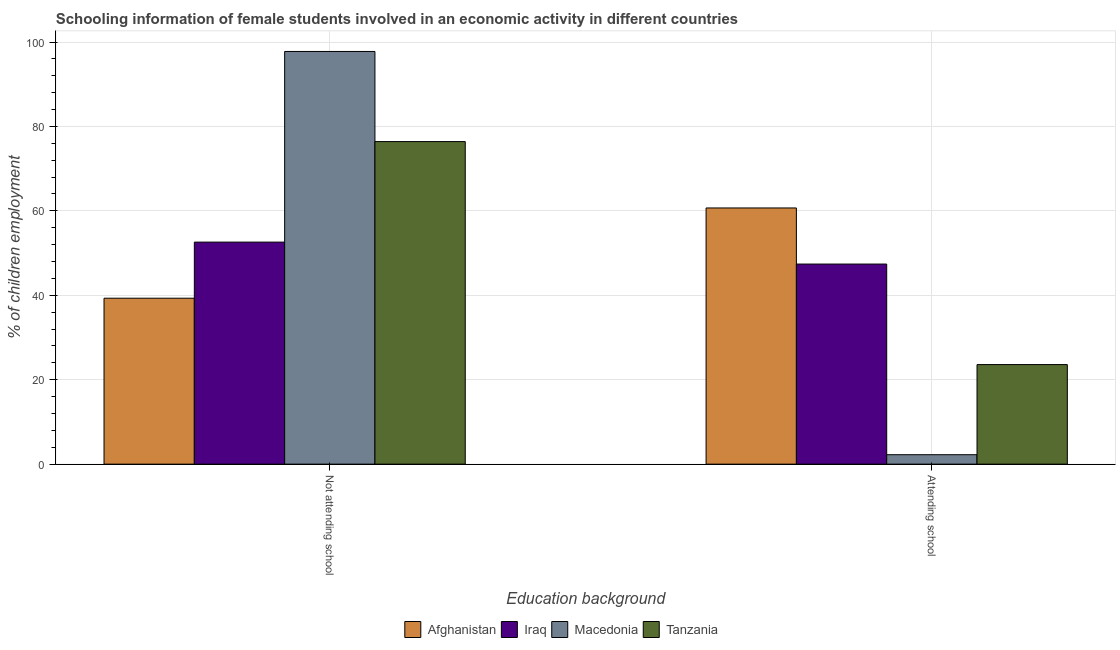How many different coloured bars are there?
Your answer should be very brief. 4. How many groups of bars are there?
Keep it short and to the point. 2. Are the number of bars on each tick of the X-axis equal?
Offer a very short reply. Yes. How many bars are there on the 1st tick from the left?
Make the answer very short. 4. How many bars are there on the 1st tick from the right?
Ensure brevity in your answer.  4. What is the label of the 1st group of bars from the left?
Make the answer very short. Not attending school. What is the percentage of employed females who are attending school in Iraq?
Provide a short and direct response. 47.4. Across all countries, what is the maximum percentage of employed females who are attending school?
Offer a very short reply. 60.69. Across all countries, what is the minimum percentage of employed females who are not attending school?
Offer a terse response. 39.31. In which country was the percentage of employed females who are attending school maximum?
Provide a succinct answer. Afghanistan. In which country was the percentage of employed females who are not attending school minimum?
Your response must be concise. Afghanistan. What is the total percentage of employed females who are attending school in the graph?
Your answer should be compact. 133.91. What is the difference between the percentage of employed females who are attending school in Macedonia and that in Iraq?
Offer a terse response. -45.16. What is the difference between the percentage of employed females who are attending school in Afghanistan and the percentage of employed females who are not attending school in Macedonia?
Give a very brief answer. -37.07. What is the average percentage of employed females who are attending school per country?
Offer a terse response. 33.48. What is the difference between the percentage of employed females who are attending school and percentage of employed females who are not attending school in Tanzania?
Provide a succinct answer. -52.83. What is the ratio of the percentage of employed females who are not attending school in Iraq to that in Macedonia?
Give a very brief answer. 0.54. Is the percentage of employed females who are attending school in Tanzania less than that in Afghanistan?
Offer a very short reply. Yes. What does the 1st bar from the left in Attending school represents?
Ensure brevity in your answer.  Afghanistan. What does the 2nd bar from the right in Not attending school represents?
Your answer should be compact. Macedonia. Are all the bars in the graph horizontal?
Offer a very short reply. No. Are the values on the major ticks of Y-axis written in scientific E-notation?
Make the answer very short. No. Does the graph contain grids?
Make the answer very short. Yes. How many legend labels are there?
Make the answer very short. 4. How are the legend labels stacked?
Your response must be concise. Horizontal. What is the title of the graph?
Provide a succinct answer. Schooling information of female students involved in an economic activity in different countries. What is the label or title of the X-axis?
Keep it short and to the point. Education background. What is the label or title of the Y-axis?
Make the answer very short. % of children employment. What is the % of children employment in Afghanistan in Not attending school?
Make the answer very short. 39.31. What is the % of children employment of Iraq in Not attending school?
Provide a succinct answer. 52.6. What is the % of children employment of Macedonia in Not attending school?
Make the answer very short. 97.76. What is the % of children employment of Tanzania in Not attending school?
Make the answer very short. 76.41. What is the % of children employment of Afghanistan in Attending school?
Keep it short and to the point. 60.69. What is the % of children employment of Iraq in Attending school?
Ensure brevity in your answer.  47.4. What is the % of children employment in Macedonia in Attending school?
Offer a very short reply. 2.24. What is the % of children employment of Tanzania in Attending school?
Your response must be concise. 23.59. Across all Education background, what is the maximum % of children employment in Afghanistan?
Give a very brief answer. 60.69. Across all Education background, what is the maximum % of children employment of Iraq?
Your response must be concise. 52.6. Across all Education background, what is the maximum % of children employment of Macedonia?
Keep it short and to the point. 97.76. Across all Education background, what is the maximum % of children employment in Tanzania?
Provide a short and direct response. 76.41. Across all Education background, what is the minimum % of children employment of Afghanistan?
Make the answer very short. 39.31. Across all Education background, what is the minimum % of children employment of Iraq?
Offer a terse response. 47.4. Across all Education background, what is the minimum % of children employment of Macedonia?
Provide a succinct answer. 2.24. Across all Education background, what is the minimum % of children employment of Tanzania?
Offer a terse response. 23.59. What is the total % of children employment in Macedonia in the graph?
Provide a succinct answer. 100. What is the difference between the % of children employment in Afghanistan in Not attending school and that in Attending school?
Give a very brief answer. -21.38. What is the difference between the % of children employment in Iraq in Not attending school and that in Attending school?
Your answer should be compact. 5.2. What is the difference between the % of children employment of Macedonia in Not attending school and that in Attending school?
Keep it short and to the point. 95.53. What is the difference between the % of children employment in Tanzania in Not attending school and that in Attending school?
Ensure brevity in your answer.  52.83. What is the difference between the % of children employment in Afghanistan in Not attending school and the % of children employment in Iraq in Attending school?
Offer a very short reply. -8.09. What is the difference between the % of children employment in Afghanistan in Not attending school and the % of children employment in Macedonia in Attending school?
Offer a very short reply. 37.07. What is the difference between the % of children employment in Afghanistan in Not attending school and the % of children employment in Tanzania in Attending school?
Keep it short and to the point. 15.72. What is the difference between the % of children employment in Iraq in Not attending school and the % of children employment in Macedonia in Attending school?
Make the answer very short. 50.36. What is the difference between the % of children employment of Iraq in Not attending school and the % of children employment of Tanzania in Attending school?
Provide a short and direct response. 29.01. What is the difference between the % of children employment in Macedonia in Not attending school and the % of children employment in Tanzania in Attending school?
Your answer should be compact. 74.18. What is the difference between the % of children employment of Afghanistan and % of children employment of Iraq in Not attending school?
Make the answer very short. -13.29. What is the difference between the % of children employment of Afghanistan and % of children employment of Macedonia in Not attending school?
Offer a very short reply. -58.45. What is the difference between the % of children employment in Afghanistan and % of children employment in Tanzania in Not attending school?
Provide a succinct answer. -37.1. What is the difference between the % of children employment in Iraq and % of children employment in Macedonia in Not attending school?
Offer a very short reply. -45.16. What is the difference between the % of children employment in Iraq and % of children employment in Tanzania in Not attending school?
Give a very brief answer. -23.81. What is the difference between the % of children employment of Macedonia and % of children employment of Tanzania in Not attending school?
Make the answer very short. 21.35. What is the difference between the % of children employment of Afghanistan and % of children employment of Iraq in Attending school?
Your answer should be compact. 13.29. What is the difference between the % of children employment of Afghanistan and % of children employment of Macedonia in Attending school?
Keep it short and to the point. 58.45. What is the difference between the % of children employment of Afghanistan and % of children employment of Tanzania in Attending school?
Provide a short and direct response. 37.1. What is the difference between the % of children employment in Iraq and % of children employment in Macedonia in Attending school?
Ensure brevity in your answer.  45.16. What is the difference between the % of children employment of Iraq and % of children employment of Tanzania in Attending school?
Ensure brevity in your answer.  23.81. What is the difference between the % of children employment of Macedonia and % of children employment of Tanzania in Attending school?
Offer a terse response. -21.35. What is the ratio of the % of children employment of Afghanistan in Not attending school to that in Attending school?
Your response must be concise. 0.65. What is the ratio of the % of children employment in Iraq in Not attending school to that in Attending school?
Offer a terse response. 1.11. What is the ratio of the % of children employment of Macedonia in Not attending school to that in Attending school?
Your answer should be very brief. 43.71. What is the ratio of the % of children employment in Tanzania in Not attending school to that in Attending school?
Offer a very short reply. 3.24. What is the difference between the highest and the second highest % of children employment in Afghanistan?
Provide a succinct answer. 21.38. What is the difference between the highest and the second highest % of children employment of Macedonia?
Your answer should be very brief. 95.53. What is the difference between the highest and the second highest % of children employment of Tanzania?
Offer a very short reply. 52.83. What is the difference between the highest and the lowest % of children employment of Afghanistan?
Provide a succinct answer. 21.38. What is the difference between the highest and the lowest % of children employment in Macedonia?
Keep it short and to the point. 95.53. What is the difference between the highest and the lowest % of children employment in Tanzania?
Provide a short and direct response. 52.83. 